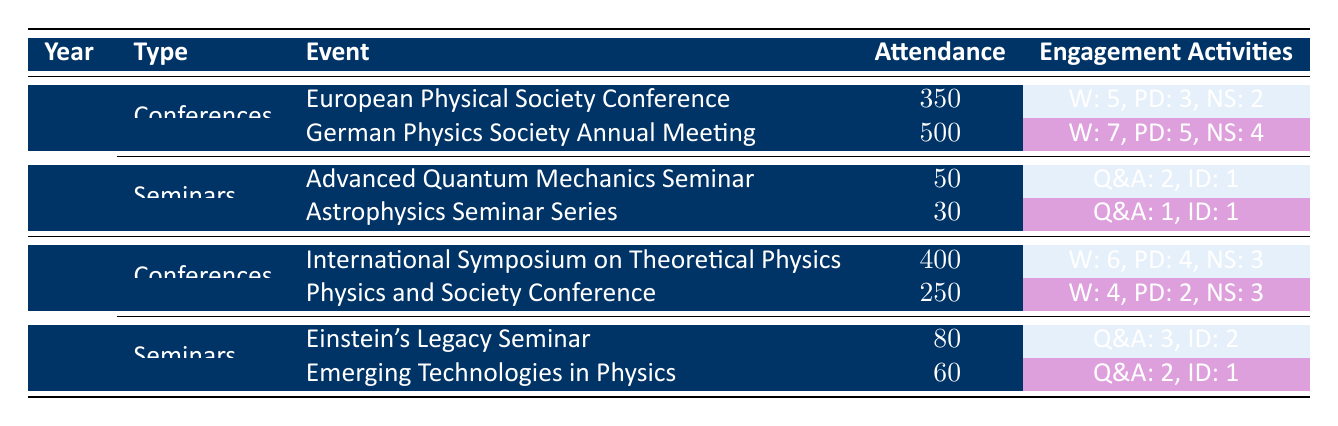What was the attendance at the German Physics Society Annual Meeting in 2022? The table directly shows that the attendance for the German Physics Society Annual Meeting in 2022 is 500.
Answer: 500 How many workshops were held at the International Symposium on Theoretical Physics in 2023? Looking at the table, it indicates that the International Symposium on Theoretical Physics in 2023 had 6 workshops.
Answer: 6 What is the total attendance for the seminars in 2022? For the Advanced Quantum Mechanics Seminar, attendance is 50, and for the Astrophysics Seminar Series, attendance is 30. Adding these together gives 50 + 30 = 80.
Answer: 80 Did the Physics and Society Conference in 2023 have more networking sessions than the Einstein's Legacy Seminar? The Physics and Society Conference had 3 networking sessions, and the Einstein's Legacy Seminar had 2. Therefore, the statement is true.
Answer: Yes Which year had a higher overall attendance for conferences: 2022 or 2023? In 2022, the total attendance for conferences is 350 (European Physical Society Conference) + 500 (German Physics Society Annual Meeting) = 850. In 2023, it is 400 (International Symposium on Theoretical Physics) + 250 (Physics and Society Conference) = 650. Since 850 > 650, 2022 had a higher overall attendance.
Answer: 2022 